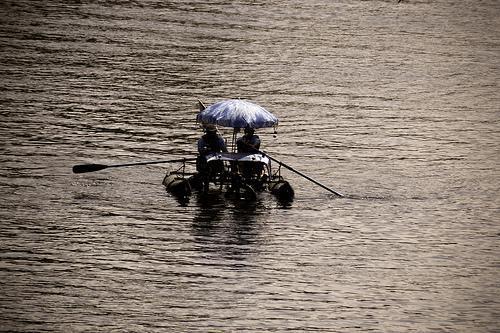How many people are there?
Give a very brief answer. 2. How many oars are out of the water?
Give a very brief answer. 1. How many boats are there?
Give a very brief answer. 1. 